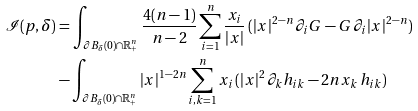<formula> <loc_0><loc_0><loc_500><loc_500>\mathcal { I } ( p , \delta ) & = \int _ { \partial B _ { \delta } ( 0 ) \cap \mathbb { R } _ { + } ^ { n } } \frac { 4 ( n - 1 ) } { n - 2 } \sum _ { i = 1 } ^ { n } \frac { x _ { i } } { | x | } \, ( | x | ^ { 2 - n } \, \partial _ { i } G - G \, \partial _ { i } | x | ^ { 2 - n } ) \\ & - \int _ { \partial B _ { \delta } ( 0 ) \cap \mathbb { R } _ { + } ^ { n } } | x | ^ { 1 - 2 n } \sum _ { i , k = 1 } ^ { n } x _ { i } \, ( | x | ^ { 2 } \, \partial _ { k } h _ { i k } - 2 n x _ { k } \, h _ { i k } )</formula> 